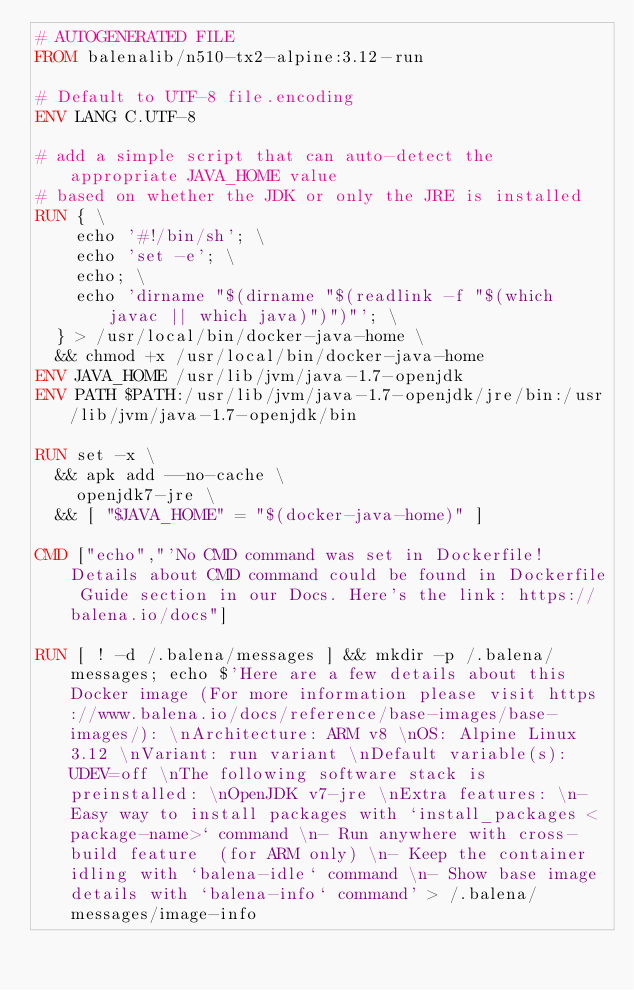Convert code to text. <code><loc_0><loc_0><loc_500><loc_500><_Dockerfile_># AUTOGENERATED FILE
FROM balenalib/n510-tx2-alpine:3.12-run

# Default to UTF-8 file.encoding
ENV LANG C.UTF-8

# add a simple script that can auto-detect the appropriate JAVA_HOME value
# based on whether the JDK or only the JRE is installed
RUN { \
		echo '#!/bin/sh'; \
		echo 'set -e'; \
		echo; \
		echo 'dirname "$(dirname "$(readlink -f "$(which javac || which java)")")"'; \
	} > /usr/local/bin/docker-java-home \
	&& chmod +x /usr/local/bin/docker-java-home
ENV JAVA_HOME /usr/lib/jvm/java-1.7-openjdk
ENV PATH $PATH:/usr/lib/jvm/java-1.7-openjdk/jre/bin:/usr/lib/jvm/java-1.7-openjdk/bin

RUN set -x \
	&& apk add --no-cache \
		openjdk7-jre \
	&& [ "$JAVA_HOME" = "$(docker-java-home)" ]

CMD ["echo","'No CMD command was set in Dockerfile! Details about CMD command could be found in Dockerfile Guide section in our Docs. Here's the link: https://balena.io/docs"]

RUN [ ! -d /.balena/messages ] && mkdir -p /.balena/messages; echo $'Here are a few details about this Docker image (For more information please visit https://www.balena.io/docs/reference/base-images/base-images/): \nArchitecture: ARM v8 \nOS: Alpine Linux 3.12 \nVariant: run variant \nDefault variable(s): UDEV=off \nThe following software stack is preinstalled: \nOpenJDK v7-jre \nExtra features: \n- Easy way to install packages with `install_packages <package-name>` command \n- Run anywhere with cross-build feature  (for ARM only) \n- Keep the container idling with `balena-idle` command \n- Show base image details with `balena-info` command' > /.balena/messages/image-info</code> 